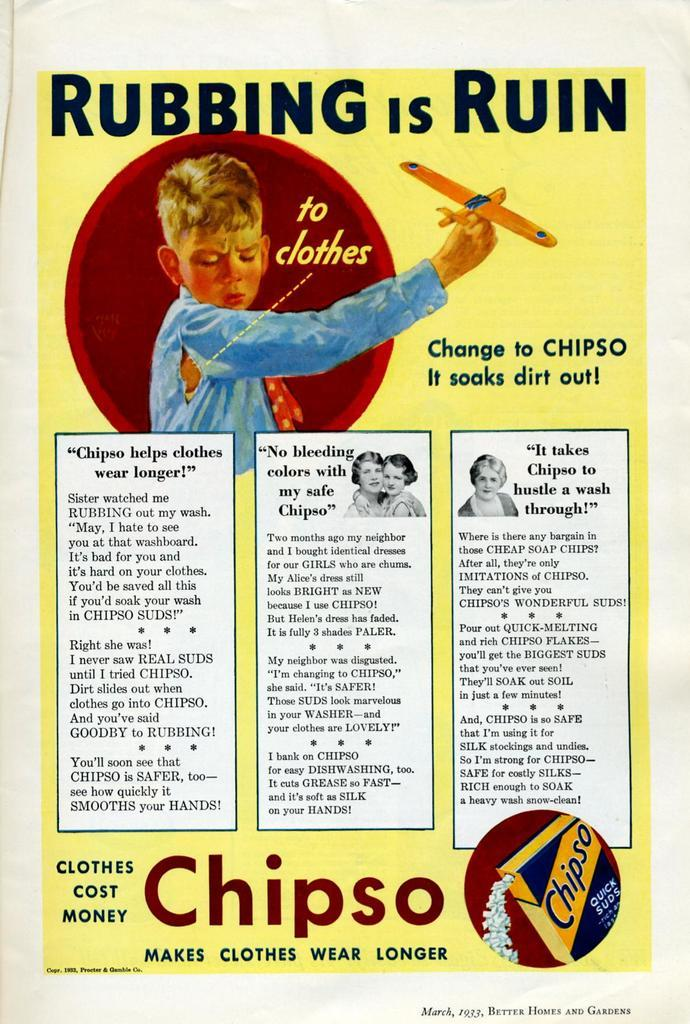Provide a one-sentence caption for the provided image. Picture of a Chipso rubbing is ruin sign about clothes. 